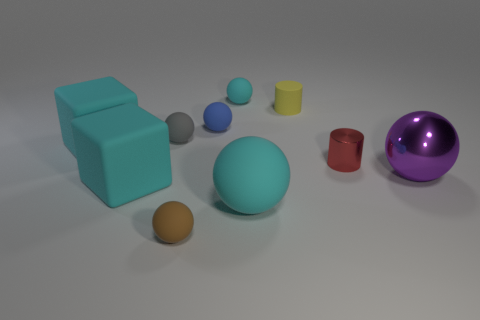Subtract 1 spheres. How many spheres are left? 5 Subtract all large cyan rubber spheres. How many spheres are left? 5 Subtract all purple balls. How many balls are left? 5 Subtract all red spheres. Subtract all purple cylinders. How many spheres are left? 6 Subtract all cylinders. How many objects are left? 8 Add 7 large cyan things. How many large cyan things are left? 10 Add 8 small cyan balls. How many small cyan balls exist? 9 Subtract 0 purple cylinders. How many objects are left? 10 Subtract all gray spheres. Subtract all large things. How many objects are left? 5 